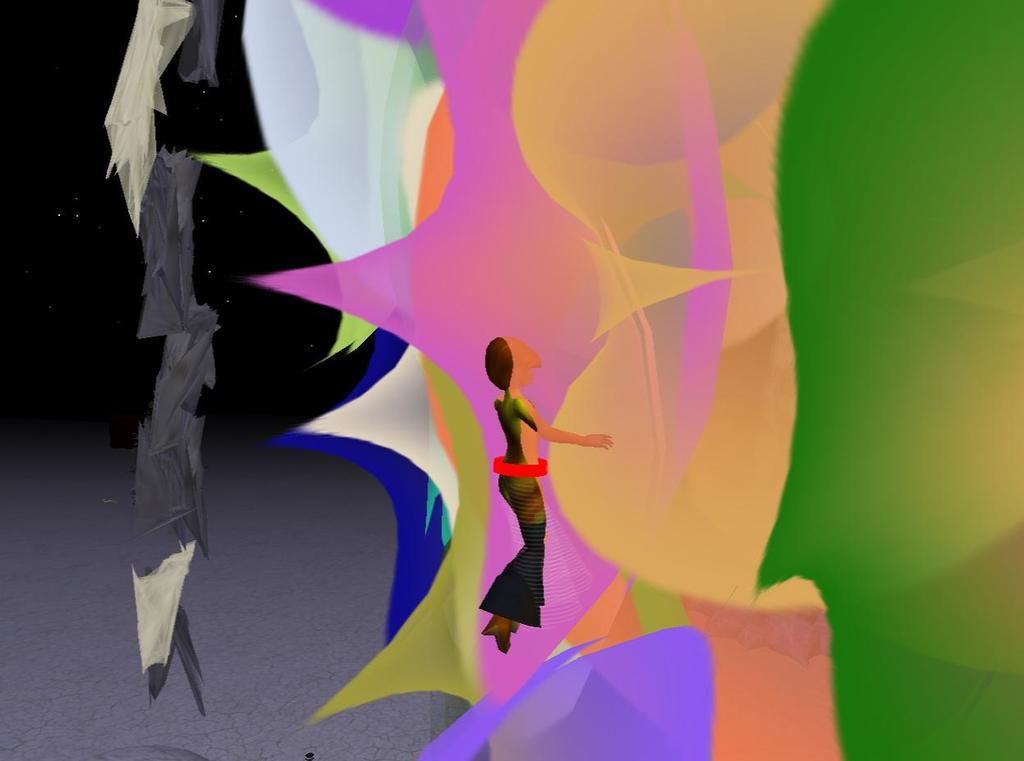What types of objects are present in the image? The image contains different shapes with different colors. Can you describe the animated character in the image? There is an animated person in the image. Where is the park located in the image? There is no park present in the image. Is the animated person crying in the image? The emotional state of the animated person cannot be determined from the image. How many spiders are visible in the image? There are no spiders present in the image. 